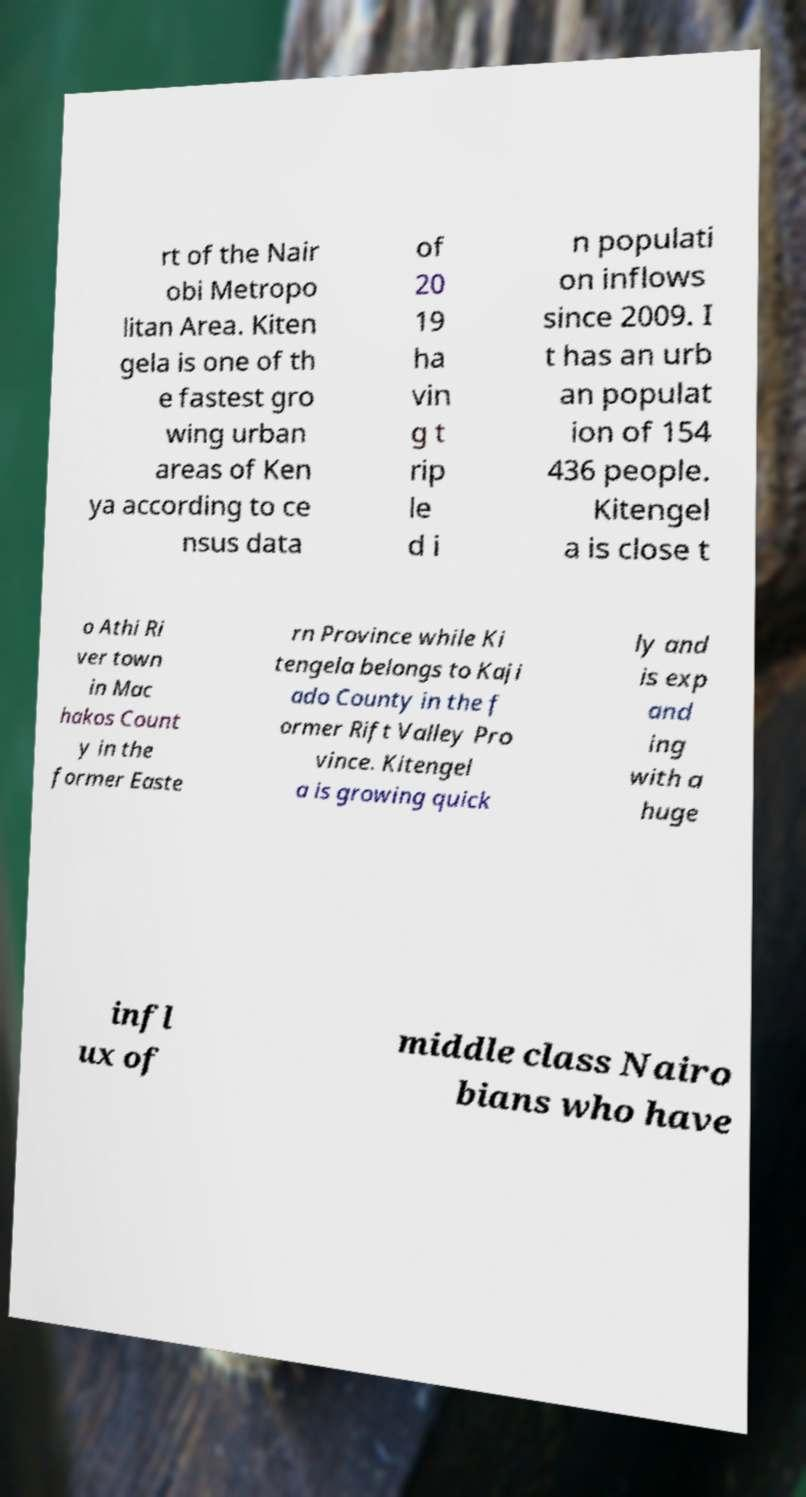What messages or text are displayed in this image? I need them in a readable, typed format. rt of the Nair obi Metropo litan Area. Kiten gela is one of th e fastest gro wing urban areas of Ken ya according to ce nsus data of 20 19 ha vin g t rip le d i n populati on inflows since 2009. I t has an urb an populat ion of 154 436 people. Kitengel a is close t o Athi Ri ver town in Mac hakos Count y in the former Easte rn Province while Ki tengela belongs to Kaji ado County in the f ormer Rift Valley Pro vince. Kitengel a is growing quick ly and is exp and ing with a huge infl ux of middle class Nairo bians who have 